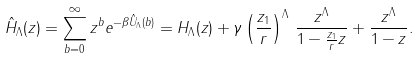<formula> <loc_0><loc_0><loc_500><loc_500>\hat { H } _ { \Lambda } ( z ) = \sum _ { b = 0 } ^ { \infty } z ^ { b } e ^ { - \beta \hat { U } _ { \Lambda } ( b ) } = H _ { \Lambda } ( z ) + \gamma \left ( \frac { z _ { 1 } } { r } \right ) ^ { \Lambda } \, \frac { z ^ { \Lambda } } { 1 - \frac { z _ { 1 } } { r } z } + \frac { z ^ { \Lambda } } { 1 - z } .</formula> 